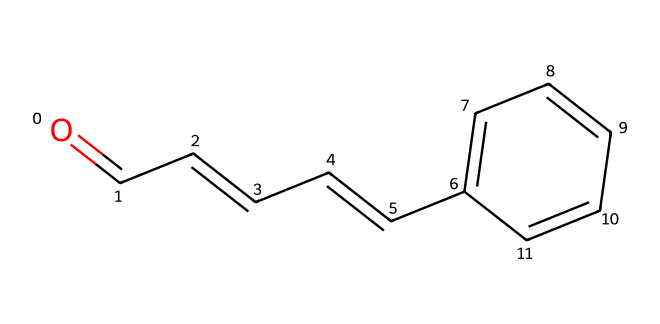What is the functional group present in cinnamaldehyde? The structure contains a carbonyl group (C=O) at the end of a carbon chain, characteristic of aldehydes.
Answer: aldehyde How many carbon atoms are in cinnamaldehyde? Counting the carbon atoms in the structure, there are 9 carbon atoms present in total.
Answer: 9 What type of bond connects the carbonyl carbon to the oxygen in cinnamaldehyde? The structure shows a double bond (C=O) between the carbonyl carbon and the oxygen atom, which is typical for aldehydes.
Answer: double bond How many hydrogen atoms are bonded to the carbonyl carbon in cinnamaldehyde? The carbonyl carbon is bonded to one hydrogen atom and is part of the aldehyde group, indicating it has one hydrogen.
Answer: 1 What type of compound is cinnamaldehyde primarily considered? Given its structure, topped with the functional group characteristics; it is primarily classified as an aldehyde.
Answer: aldehyde What is the role of the double bond in the carbon chain of cinnamaldehyde? The double bond in the carbon chain indicates it is an alkene, contributing to the overall reactivity and properties of the compound.
Answer: alkene Does cinnamaldehyde contain any rings in its structure? Analyzing the structure shows that there is a phenyl ring (a six-membered carbon ring) attached to the molecule, indicating it does contain a ring structure.
Answer: yes 